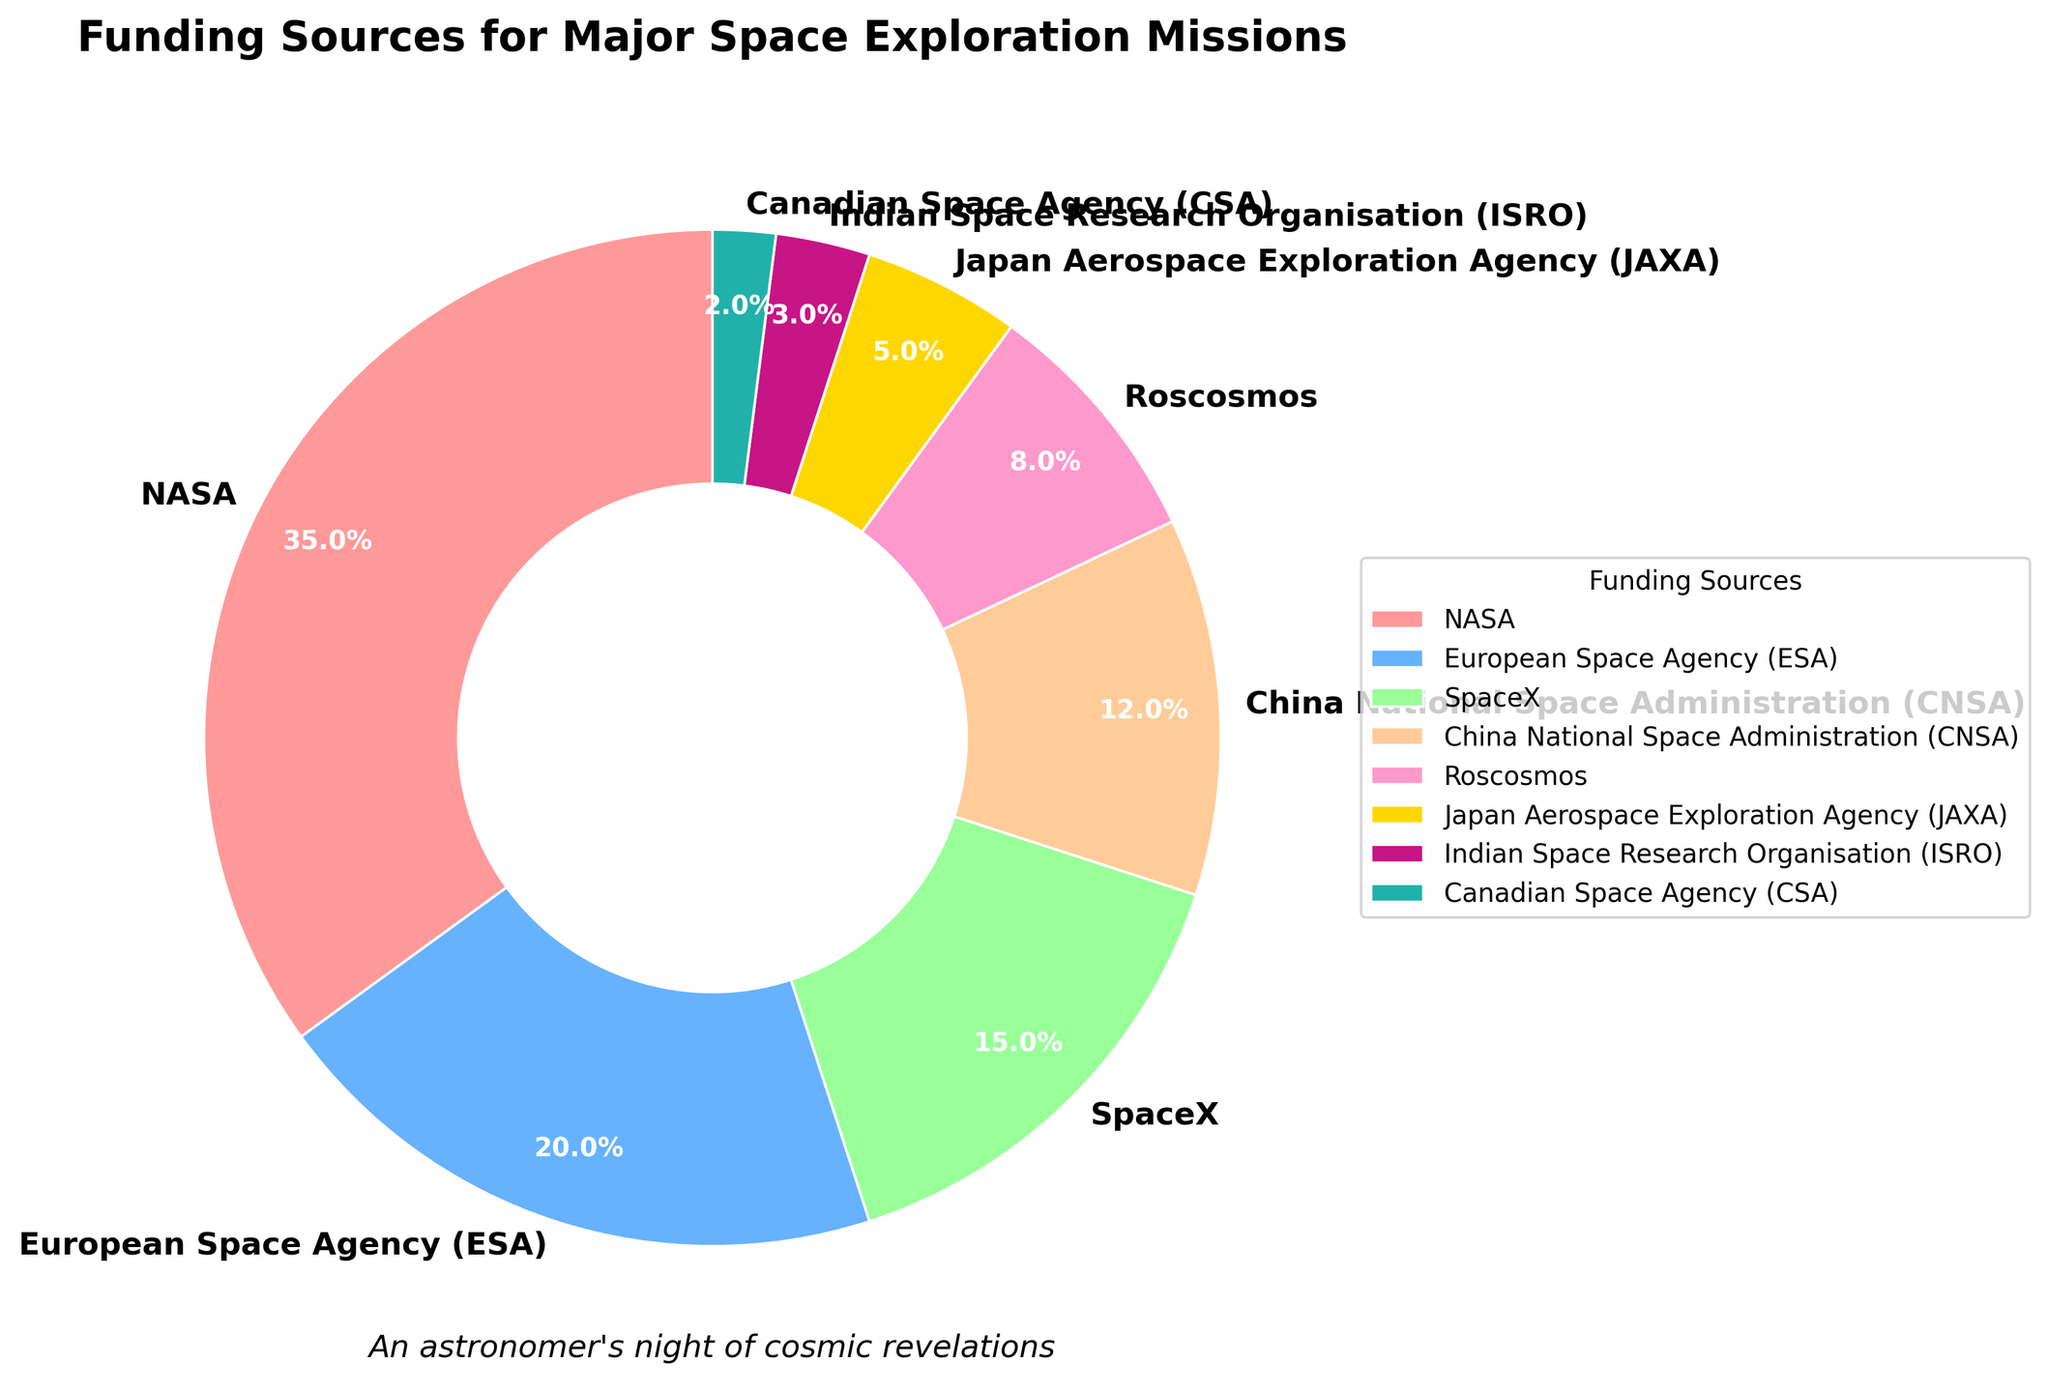What is the total percentage of funding from China National Space Administration (CNSA) and Japan Aerospace Exploration Agency (JAXA)? CNSA has 12% and JAXA has 5%. Adding these together gives 12% + 5% = 17%.
Answer: 17% Which funding source contributes the most to space exploration missions? By looking at the sizes of the pie chart segments, NASA has the largest segment, indicating it contributes the most.
Answer: NASA How much more funding does NASA provide compared to the European Space Agency (ESA)? NASA provides 35%, while ESA provides 20%. The difference is 35% - 20% = 15%.
Answer: 15% Which funding sources contribute less than 10% each to the total funding? Looking at the pie chart, those funding sources are Roscosmos (8%), JAXA (5%), ISRO (3%), and CSA (2%).
Answer: Roscosmos, JAXA, ISRO, and CSA What is the combined contribution of SpaceX and Roscosmos? SpaceX has 15% and Roscosmos has 8%. Adding these gives 15% + 8% = 23%.
Answer: 23% Which segment has the second-largest contribution, and what is its percentage? The second-largest segment in the pie chart is contributed by the European Space Agency (ESA) with 20%.
Answer: ESA, 20% Is the funding from NASA more than the combined funding from CNSA, JAXA, and ISRO? NASA provides 35%. The combined funding from CNSA, JAXA, and ISRO is 12% + 5% + 3% = 20%. Since 35% > 20%, NASA provides more.
Answer: Yes Which funding source is represented by the green segment in the pie chart? The green segment in the pie chart corresponds to the third color after pink and blue, which is associated with SpaceX.
Answer: SpaceX 